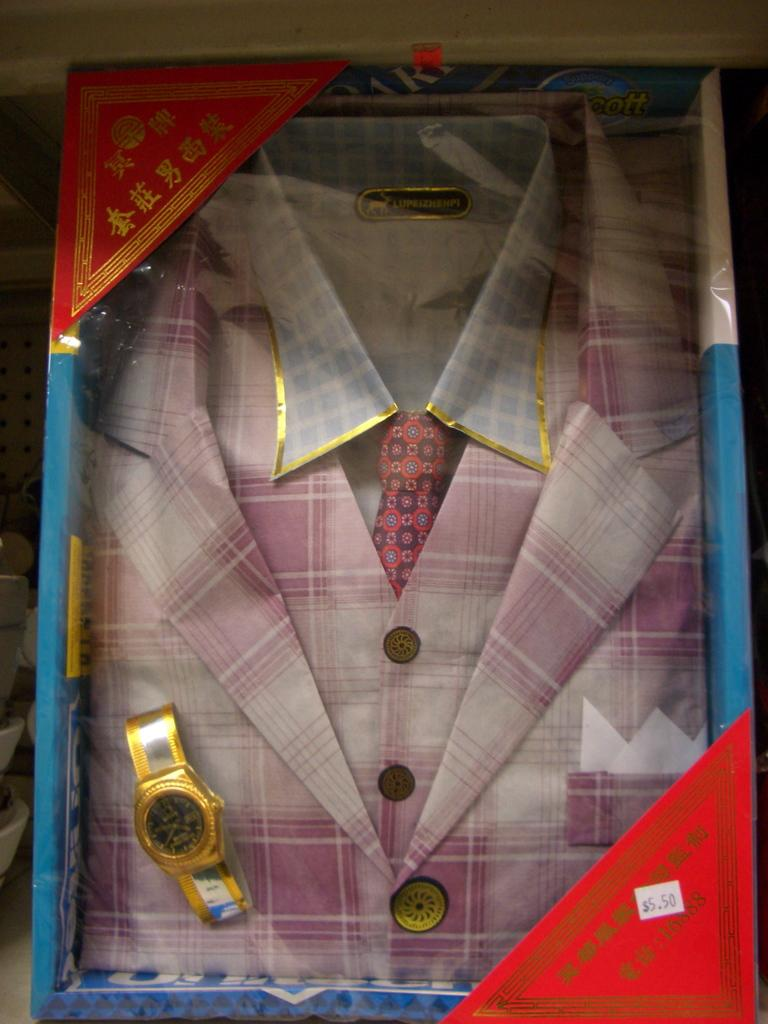Provide a one-sentence caption for the provided image. The price on the clothing in the box is 5.50. 